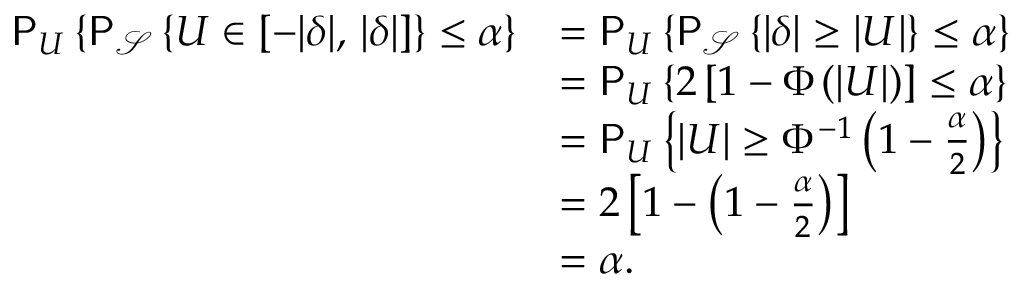Convert formula to latex. <formula><loc_0><loc_0><loc_500><loc_500>\begin{array} { r l } { P _ { U } \left \{ P _ { \mathcal { S } } \left \{ U \in [ - | \delta | , \, | \delta | ] \right \} \leq \alpha \right \} } & { = P _ { U } \left \{ P _ { \mathcal { S } } \left \{ | \delta | \geq \left | U \right | \right \} \leq \alpha \right \} } \\ & { = P _ { U } \left \{ 2 \left [ 1 - \Phi \left ( \left | U \right | \right ) \right ] \leq \alpha \right \} } \\ & { = P _ { U } \left \{ | U | \geq \Phi ^ { - 1 } \left ( 1 - \frac { \alpha } { 2 } \right ) \right \} } \\ & { = 2 \left [ 1 - \left ( 1 - \frac { \alpha } { 2 } \right ) \right ] } \\ & { = \alpha . } \end{array}</formula> 